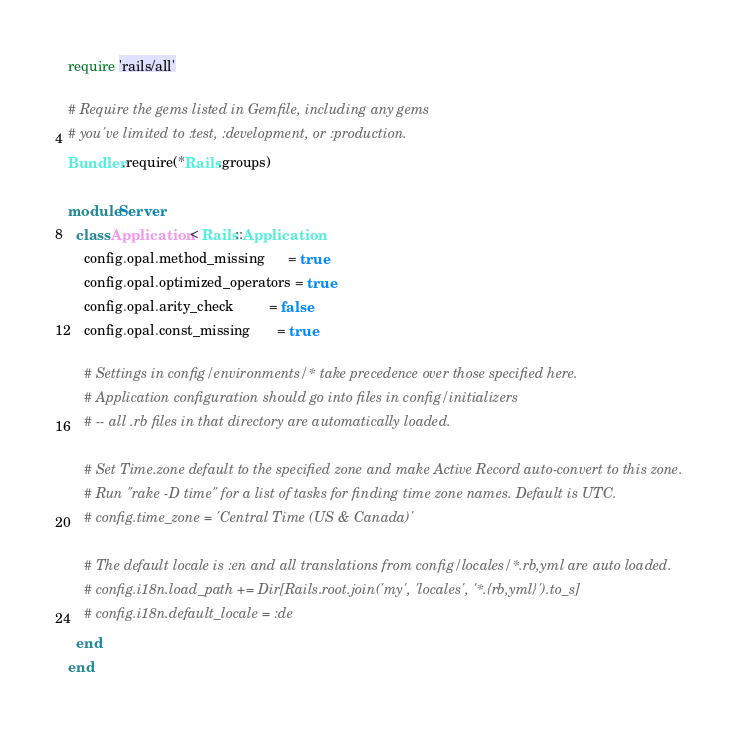Convert code to text. <code><loc_0><loc_0><loc_500><loc_500><_Ruby_>
require 'rails/all'

# Require the gems listed in Gemfile, including any gems
# you've limited to :test, :development, or :production.
Bundler.require(*Rails.groups)

module Server
  class Application < Rails::Application
    config.opal.method_missing      = true
    config.opal.optimized_operators = true
    config.opal.arity_check         = false
    config.opal.const_missing       = true

    # Settings in config/environments/* take precedence over those specified here.
    # Application configuration should go into files in config/initializers
    # -- all .rb files in that directory are automatically loaded.

    # Set Time.zone default to the specified zone and make Active Record auto-convert to this zone.
    # Run "rake -D time" for a list of tasks for finding time zone names. Default is UTC.
    # config.time_zone = 'Central Time (US & Canada)'

    # The default locale is :en and all translations from config/locales/*.rb,yml are auto loaded.
    # config.i18n.load_path += Dir[Rails.root.join('my', 'locales', '*.{rb,yml}').to_s]
    # config.i18n.default_locale = :de
  end
end
</code> 